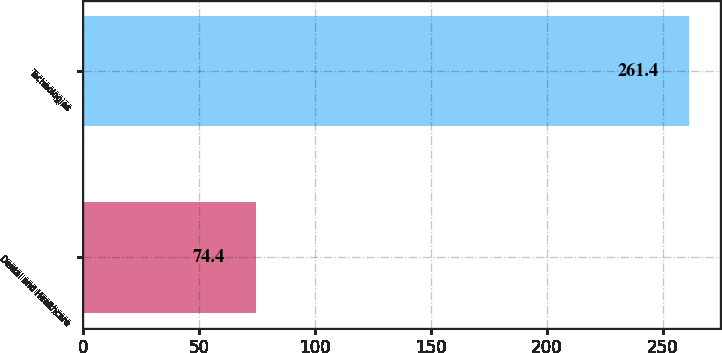<chart> <loc_0><loc_0><loc_500><loc_500><bar_chart><fcel>Dental and Healthcare<fcel>Technologies<nl><fcel>74.4<fcel>261.4<nl></chart> 